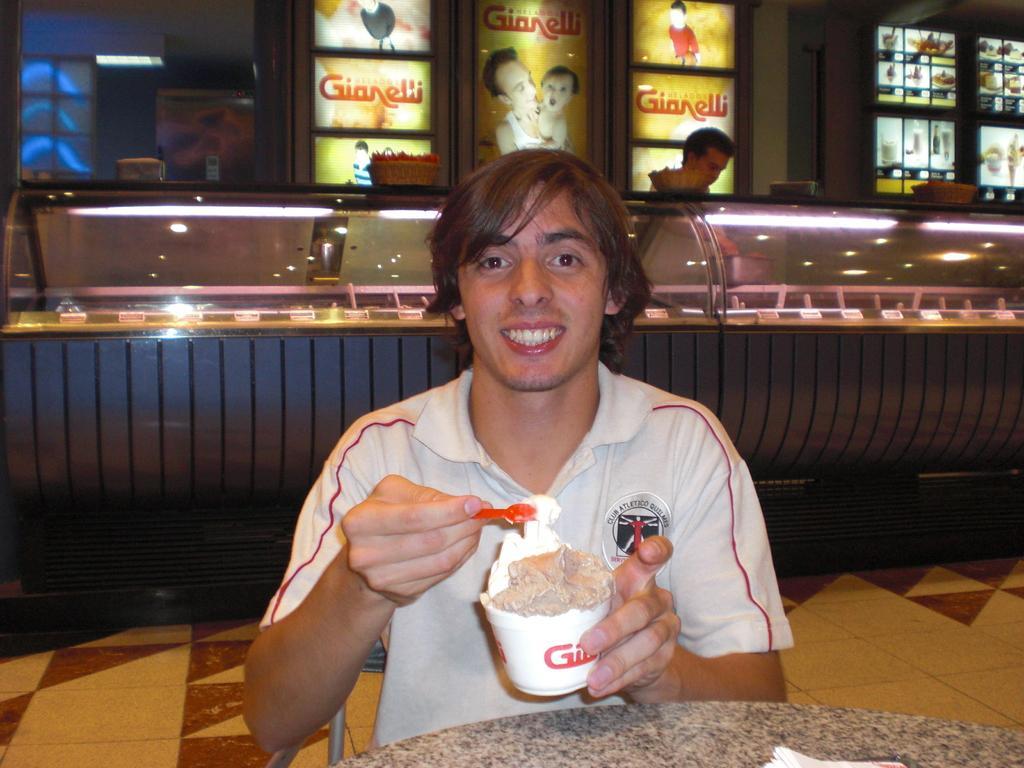Can you describe this image briefly? In this image in the middle there is a man, he wears a t shirt, he is holding a cup of ice cream, in front of him there is a table on that there are tissues. In the background there is a man, he wears a jacket and there are lights, posters, glass and floor. 